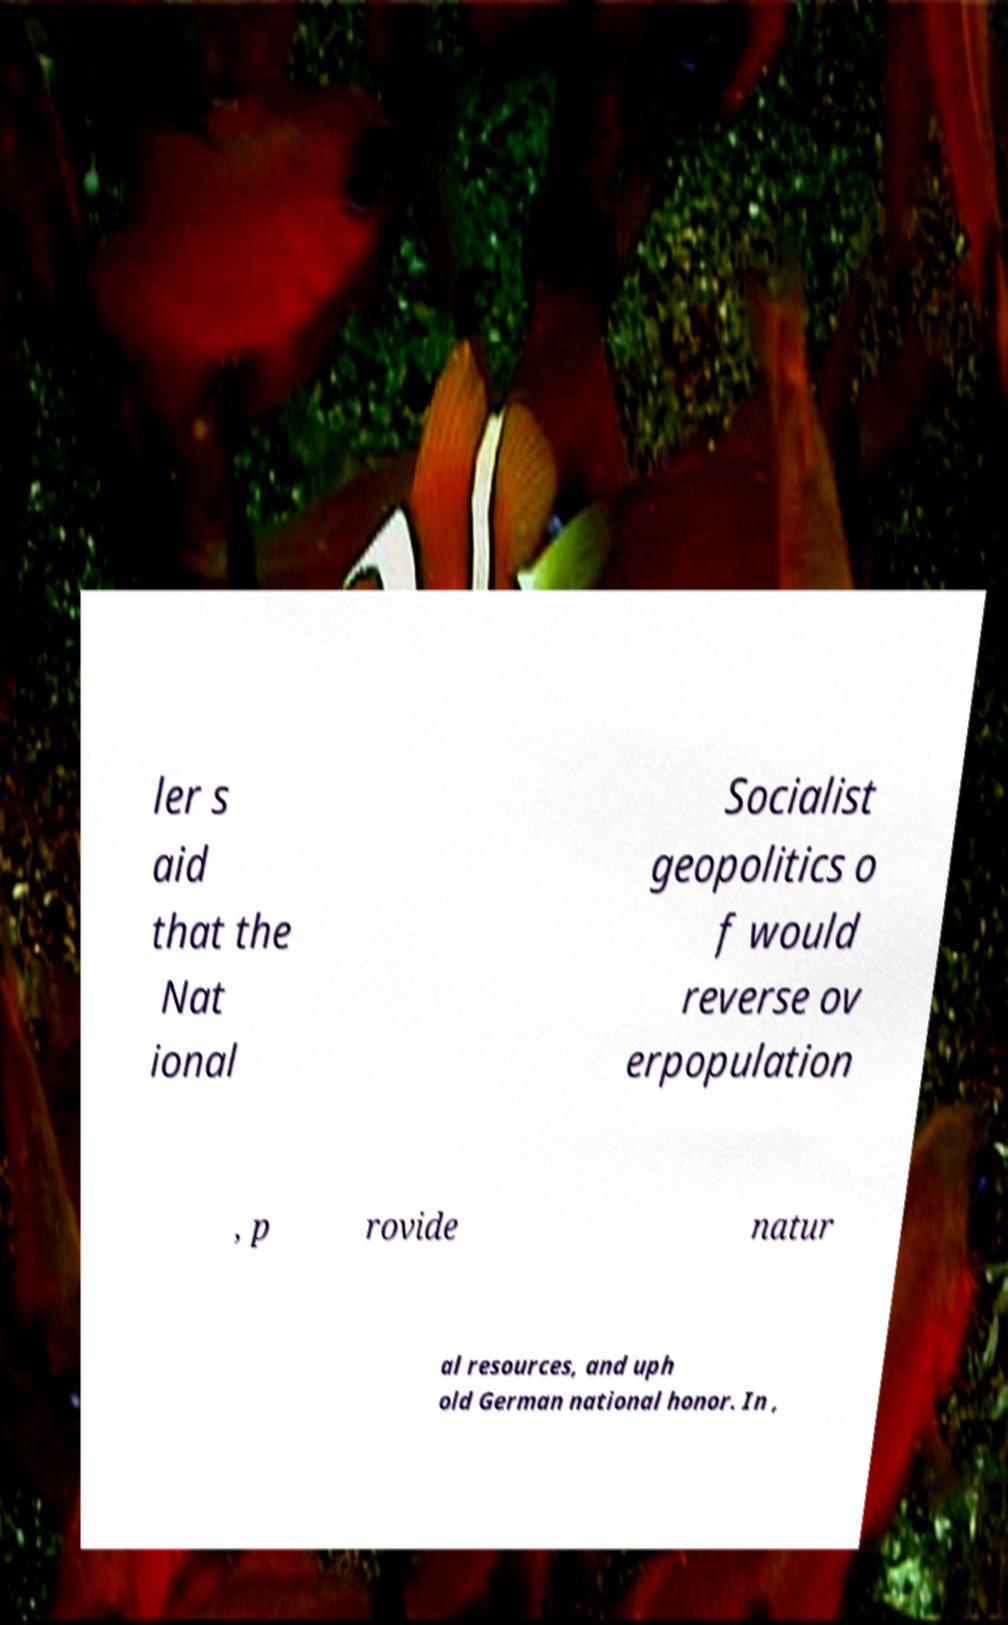Could you extract and type out the text from this image? ler s aid that the Nat ional Socialist geopolitics o f would reverse ov erpopulation , p rovide natur al resources, and uph old German national honor. In , 